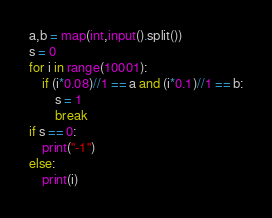Convert code to text. <code><loc_0><loc_0><loc_500><loc_500><_Python_>a,b = map(int,input().split())
s = 0
for i in range(10001):
    if (i*0.08)//1 == a and (i*0.1)//1 == b:
        s = 1
        break
if s == 0:
    print("-1")
else:
    print(i)
</code> 